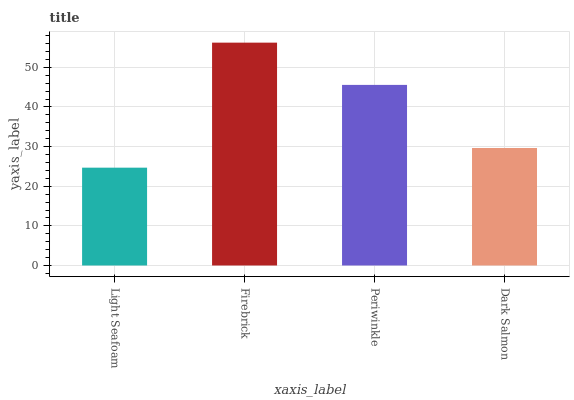Is Light Seafoam the minimum?
Answer yes or no. Yes. Is Firebrick the maximum?
Answer yes or no. Yes. Is Periwinkle the minimum?
Answer yes or no. No. Is Periwinkle the maximum?
Answer yes or no. No. Is Firebrick greater than Periwinkle?
Answer yes or no. Yes. Is Periwinkle less than Firebrick?
Answer yes or no. Yes. Is Periwinkle greater than Firebrick?
Answer yes or no. No. Is Firebrick less than Periwinkle?
Answer yes or no. No. Is Periwinkle the high median?
Answer yes or no. Yes. Is Dark Salmon the low median?
Answer yes or no. Yes. Is Light Seafoam the high median?
Answer yes or no. No. Is Light Seafoam the low median?
Answer yes or no. No. 